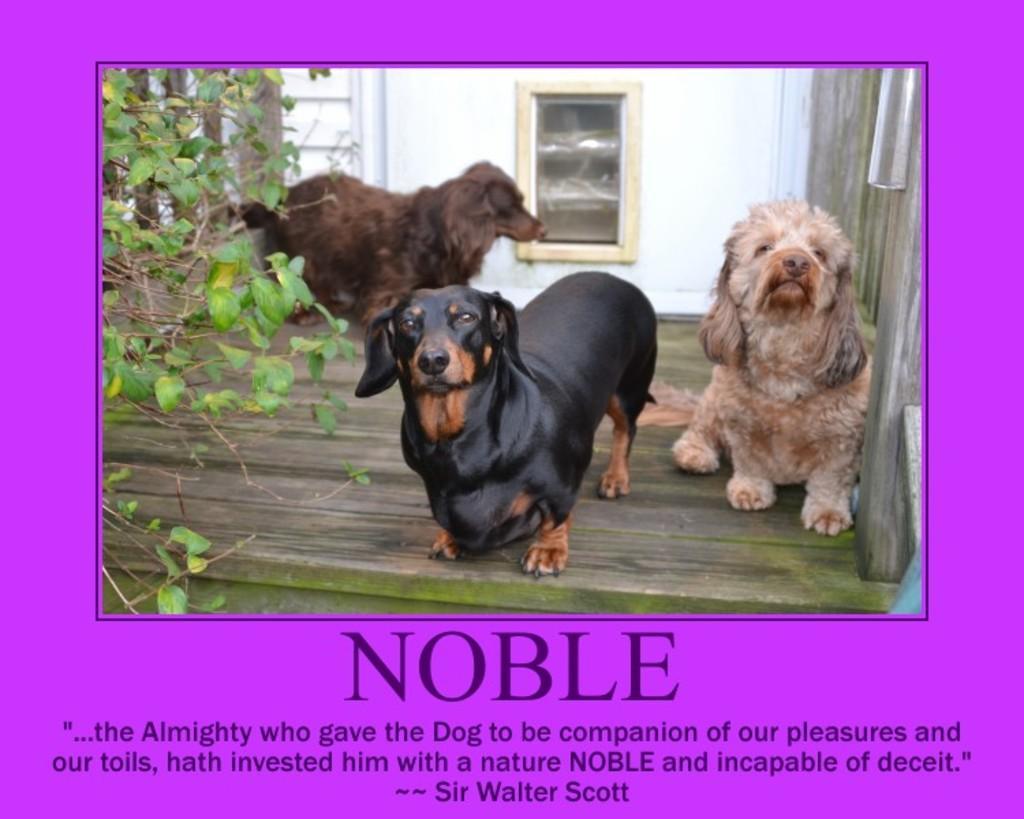Could you give a brief overview of what you see in this image? In this image we can see a poster in which we can see dogs, plants, window and we can see some text written at the bottom.. 